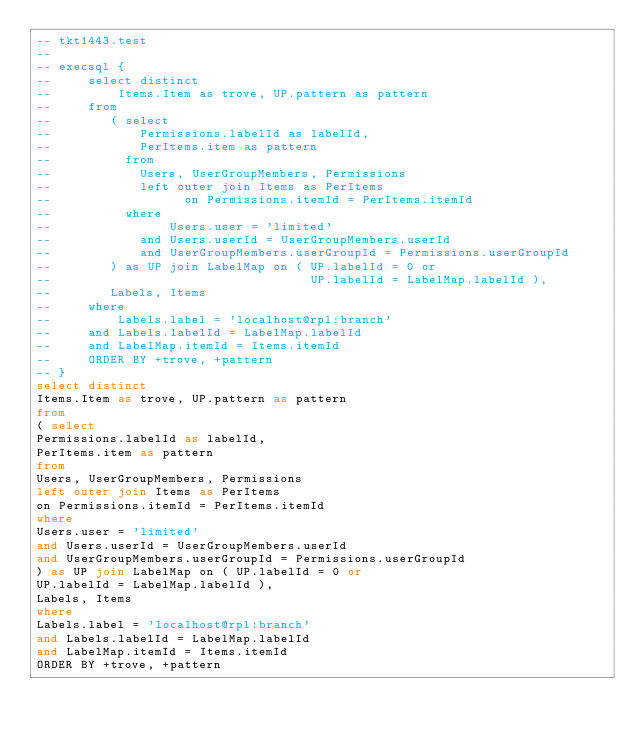Convert code to text. <code><loc_0><loc_0><loc_500><loc_500><_SQL_>-- tkt1443.test
-- 
-- execsql {
--     select distinct
--         Items.Item as trove, UP.pattern as pattern
--     from
--        ( select
--            Permissions.labelId as labelId,
--            PerItems.item as pattern
--          from
--            Users, UserGroupMembers, Permissions
--            left outer join Items as PerItems
--                  on Permissions.itemId = PerItems.itemId
--          where
--                Users.user = 'limited'
--            and Users.userId = UserGroupMembers.userId
--            and UserGroupMembers.userGroupId = Permissions.userGroupId
--        ) as UP join LabelMap on ( UP.labelId = 0 or
--                                   UP.labelId = LabelMap.labelId ),
--        Labels, Items
--     where
--         Labels.label = 'localhost@rpl:branch'
--     and Labels.labelId = LabelMap.labelId
--     and LabelMap.itemId = Items.itemId
--     ORDER BY +trove, +pattern
-- }
select distinct
Items.Item as trove, UP.pattern as pattern
from
( select
Permissions.labelId as labelId,
PerItems.item as pattern
from
Users, UserGroupMembers, Permissions
left outer join Items as PerItems
on Permissions.itemId = PerItems.itemId
where
Users.user = 'limited'
and Users.userId = UserGroupMembers.userId
and UserGroupMembers.userGroupId = Permissions.userGroupId
) as UP join LabelMap on ( UP.labelId = 0 or
UP.labelId = LabelMap.labelId ),
Labels, Items
where
Labels.label = 'localhost@rpl:branch'
and Labels.labelId = LabelMap.labelId
and LabelMap.itemId = Items.itemId
ORDER BY +trove, +pattern</code> 